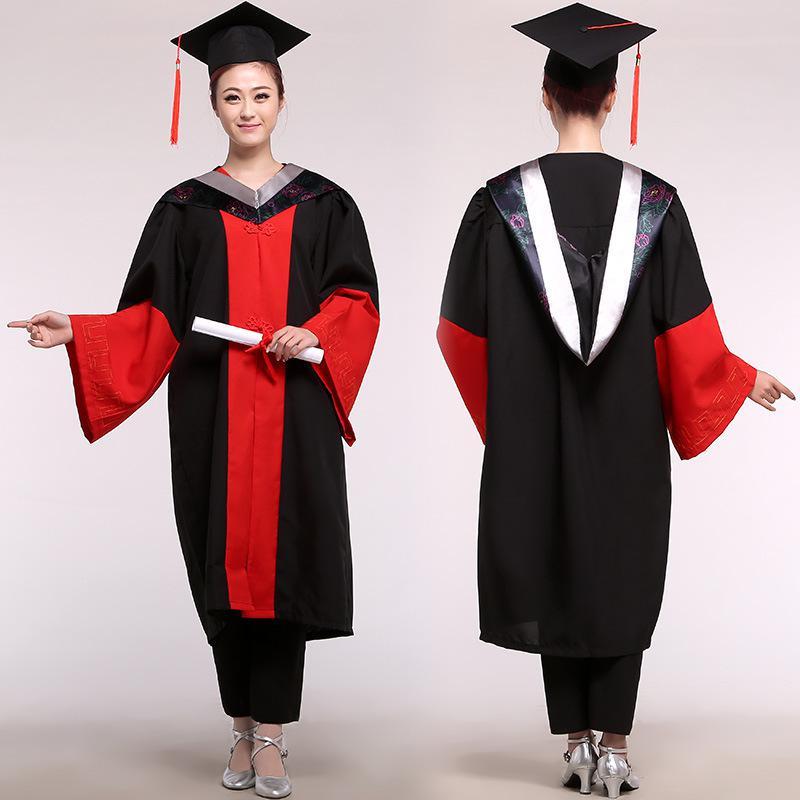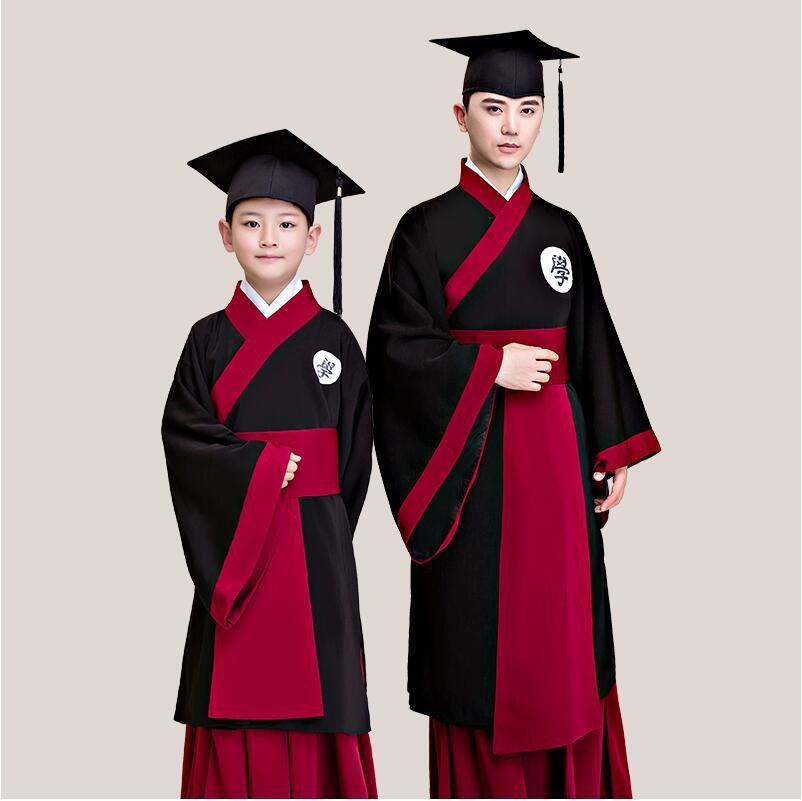The first image is the image on the left, the second image is the image on the right. Examine the images to the left and right. Is the description "A student is holding a diploma with her left hand and pointing with her right hand." accurate? Answer yes or no. Yes. The first image is the image on the left, the second image is the image on the right. For the images shown, is this caption "Someone is carrying a book next to someone who isn't carrying a book." true? Answer yes or no. No. 